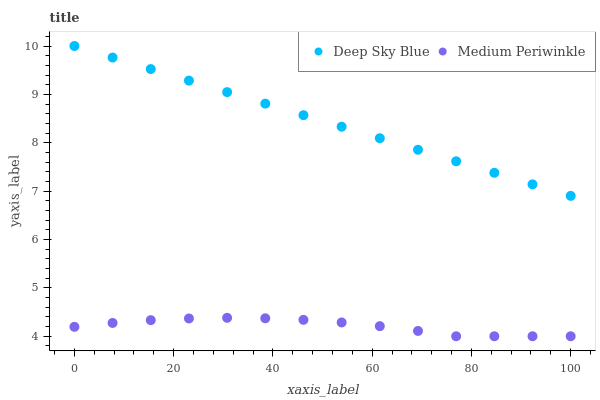Does Medium Periwinkle have the minimum area under the curve?
Answer yes or no. Yes. Does Deep Sky Blue have the maximum area under the curve?
Answer yes or no. Yes. Does Deep Sky Blue have the minimum area under the curve?
Answer yes or no. No. Is Deep Sky Blue the smoothest?
Answer yes or no. Yes. Is Medium Periwinkle the roughest?
Answer yes or no. Yes. Is Deep Sky Blue the roughest?
Answer yes or no. No. Does Medium Periwinkle have the lowest value?
Answer yes or no. Yes. Does Deep Sky Blue have the lowest value?
Answer yes or no. No. Does Deep Sky Blue have the highest value?
Answer yes or no. Yes. Is Medium Periwinkle less than Deep Sky Blue?
Answer yes or no. Yes. Is Deep Sky Blue greater than Medium Periwinkle?
Answer yes or no. Yes. Does Medium Periwinkle intersect Deep Sky Blue?
Answer yes or no. No. 